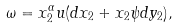Convert formula to latex. <formula><loc_0><loc_0><loc_500><loc_500>\omega = x _ { 2 } ^ { \alpha } u ( d x _ { 2 } + x _ { 2 } \psi d y _ { 2 } ) ,</formula> 